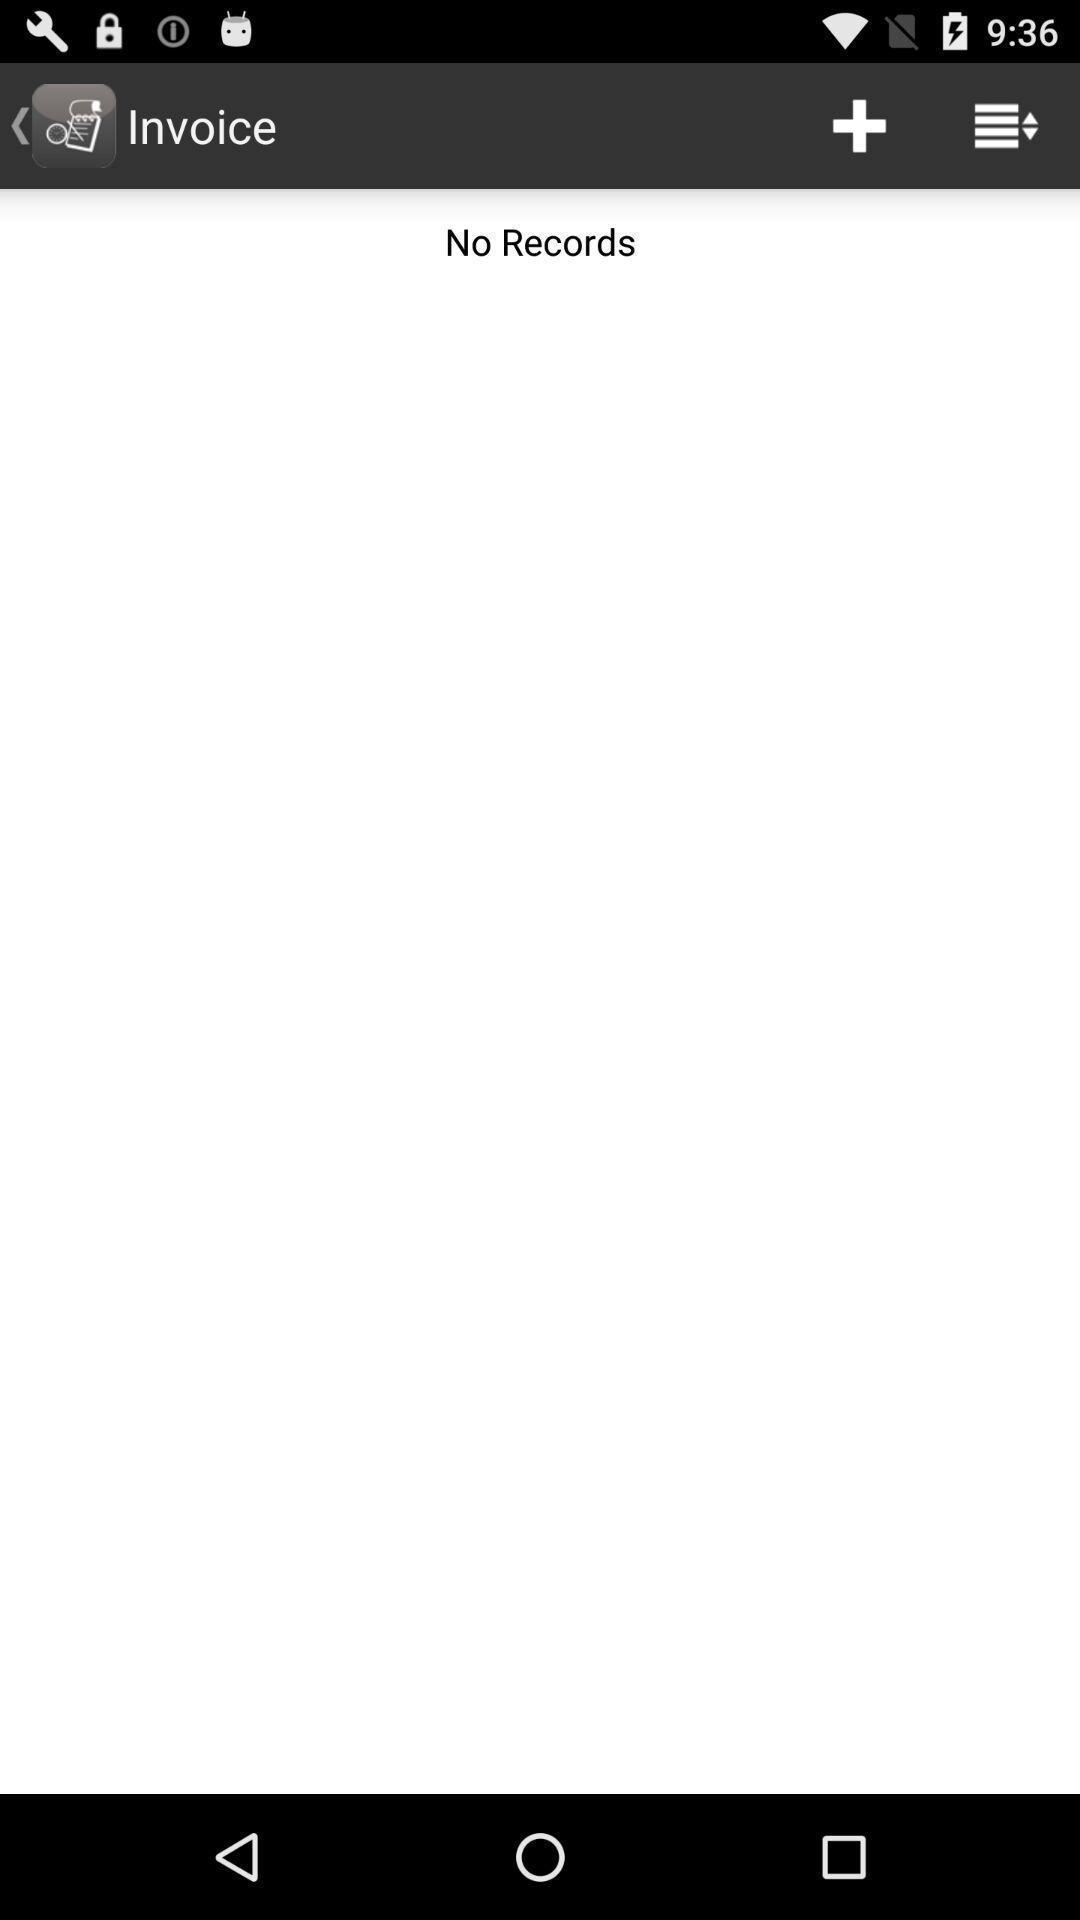Tell me about the visual elements in this screen capture. Page is showing no records. 